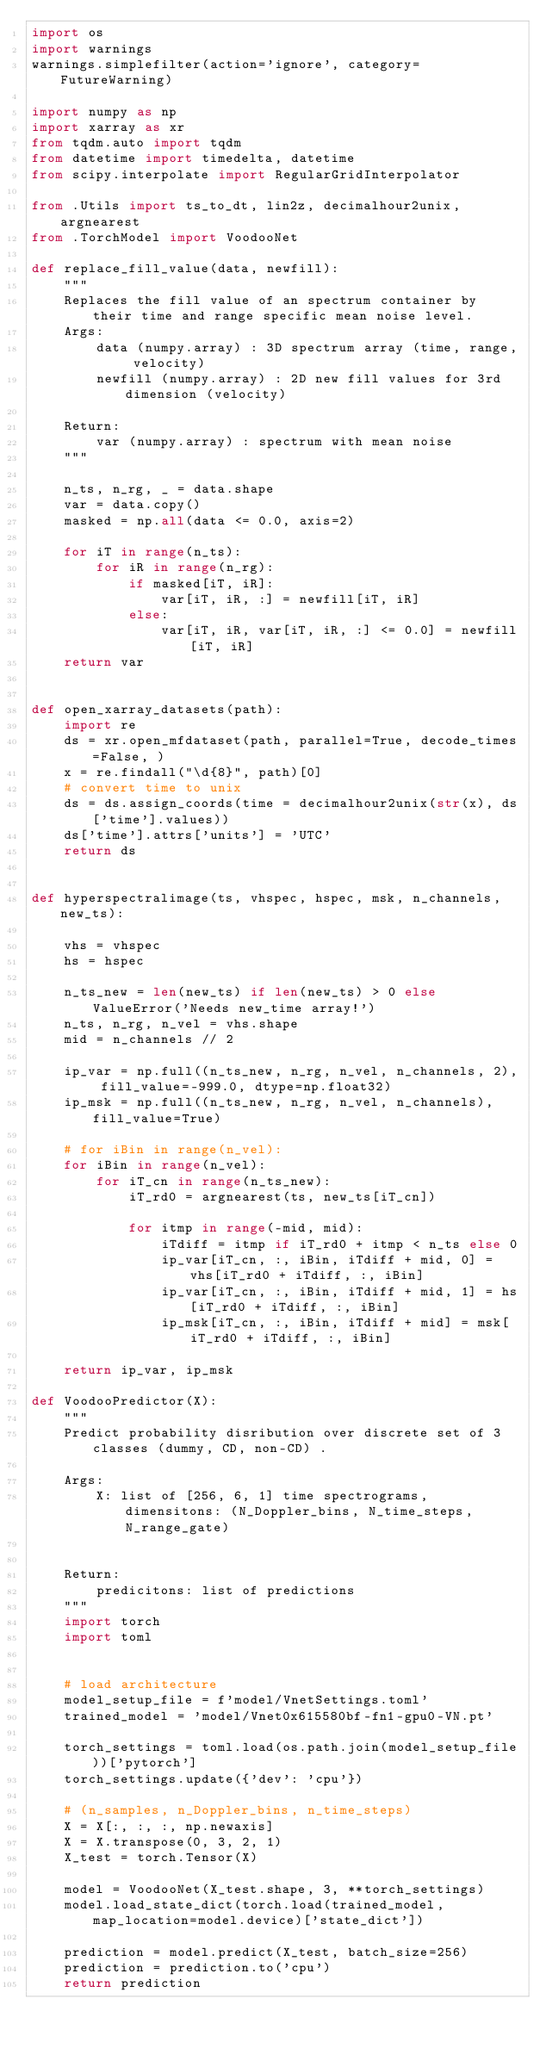Convert code to text. <code><loc_0><loc_0><loc_500><loc_500><_Python_>import os
import warnings
warnings.simplefilter(action='ignore', category=FutureWarning)

import numpy as np
import xarray as xr
from tqdm.auto import tqdm
from datetime import timedelta, datetime
from scipy.interpolate import RegularGridInterpolator

from .Utils import ts_to_dt, lin2z, decimalhour2unix, argnearest
from .TorchModel import VoodooNet

def replace_fill_value(data, newfill):
    """
    Replaces the fill value of an spectrum container by their time and range specific mean noise level.
    Args:
        data (numpy.array) : 3D spectrum array (time, range, velocity)
        newfill (numpy.array) : 2D new fill values for 3rd dimension (velocity)

    Return:
        var (numpy.array) : spectrum with mean noise
    """

    n_ts, n_rg, _ = data.shape
    var = data.copy()
    masked = np.all(data <= 0.0, axis=2)

    for iT in range(n_ts):
        for iR in range(n_rg):
            if masked[iT, iR]:
                var[iT, iR, :] = newfill[iT, iR]
            else:
                var[iT, iR, var[iT, iR, :] <= 0.0] = newfill[iT, iR]
    return var


def open_xarray_datasets(path):
    import re
    ds = xr.open_mfdataset(path, parallel=True, decode_times=False, )
    x = re.findall("\d{8}", path)[0]
    # convert time to unix
    ds = ds.assign_coords(time = decimalhour2unix(str(x), ds['time'].values))
    ds['time'].attrs['units'] = 'UTC'
    return ds


def hyperspectralimage(ts, vhspec, hspec, msk, n_channels, new_ts):
    
    vhs = vhspec
    hs = hspec
    
    n_ts_new = len(new_ts) if len(new_ts) > 0 else ValueError('Needs new_time array!')
    n_ts, n_rg, n_vel = vhs.shape
    mid = n_channels // 2

    ip_var = np.full((n_ts_new, n_rg, n_vel, n_channels, 2), fill_value=-999.0, dtype=np.float32)
    ip_msk = np.full((n_ts_new, n_rg, n_vel, n_channels), fill_value=True)

    # for iBin in range(n_vel):
    for iBin in range(n_vel):
        for iT_cn in range(n_ts_new):
            iT_rd0 = argnearest(ts, new_ts[iT_cn])

            for itmp in range(-mid, mid):
                iTdiff = itmp if iT_rd0 + itmp < n_ts else 0
                ip_var[iT_cn, :, iBin, iTdiff + mid, 0] = vhs[iT_rd0 + iTdiff, :, iBin]
                ip_var[iT_cn, :, iBin, iTdiff + mid, 1] = hs[iT_rd0 + iTdiff, :, iBin]
                ip_msk[iT_cn, :, iBin, iTdiff + mid] = msk[iT_rd0 + iTdiff, :, iBin]

    return ip_var, ip_msk

def VoodooPredictor(X):
    """
    Predict probability disribution over discrete set of 3 classes (dummy, CD, non-CD) .
    
    Args:
        X: list of [256, 6, 1] time spectrograms, dimensitons: (N_Doppler_bins, N_time_steps, N_range_gate)
        
        
    Return:
        predicitons: list of predictions 
    """
    import torch
    import toml

    
    # load architecture
    model_setup_file = f'model/VnetSettings.toml'
    trained_model = 'model/Vnet0x615580bf-fn1-gpu0-VN.pt'
    
    torch_settings = toml.load(os.path.join(model_setup_file))['pytorch']
    torch_settings.update({'dev': 'cpu'})
    
    # (n_samples, n_Doppler_bins, n_time_steps)
    X = X[:, :, :, np.newaxis]
    X = X.transpose(0, 3, 2, 1)
    X_test = torch.Tensor(X)

    model = VoodooNet(X_test.shape, 3, **torch_settings)
    model.load_state_dict(torch.load(trained_model, map_location=model.device)['state_dict'])

    prediction = model.predict(X_test, batch_size=256)
    prediction = prediction.to('cpu')
    return prediction
</code> 